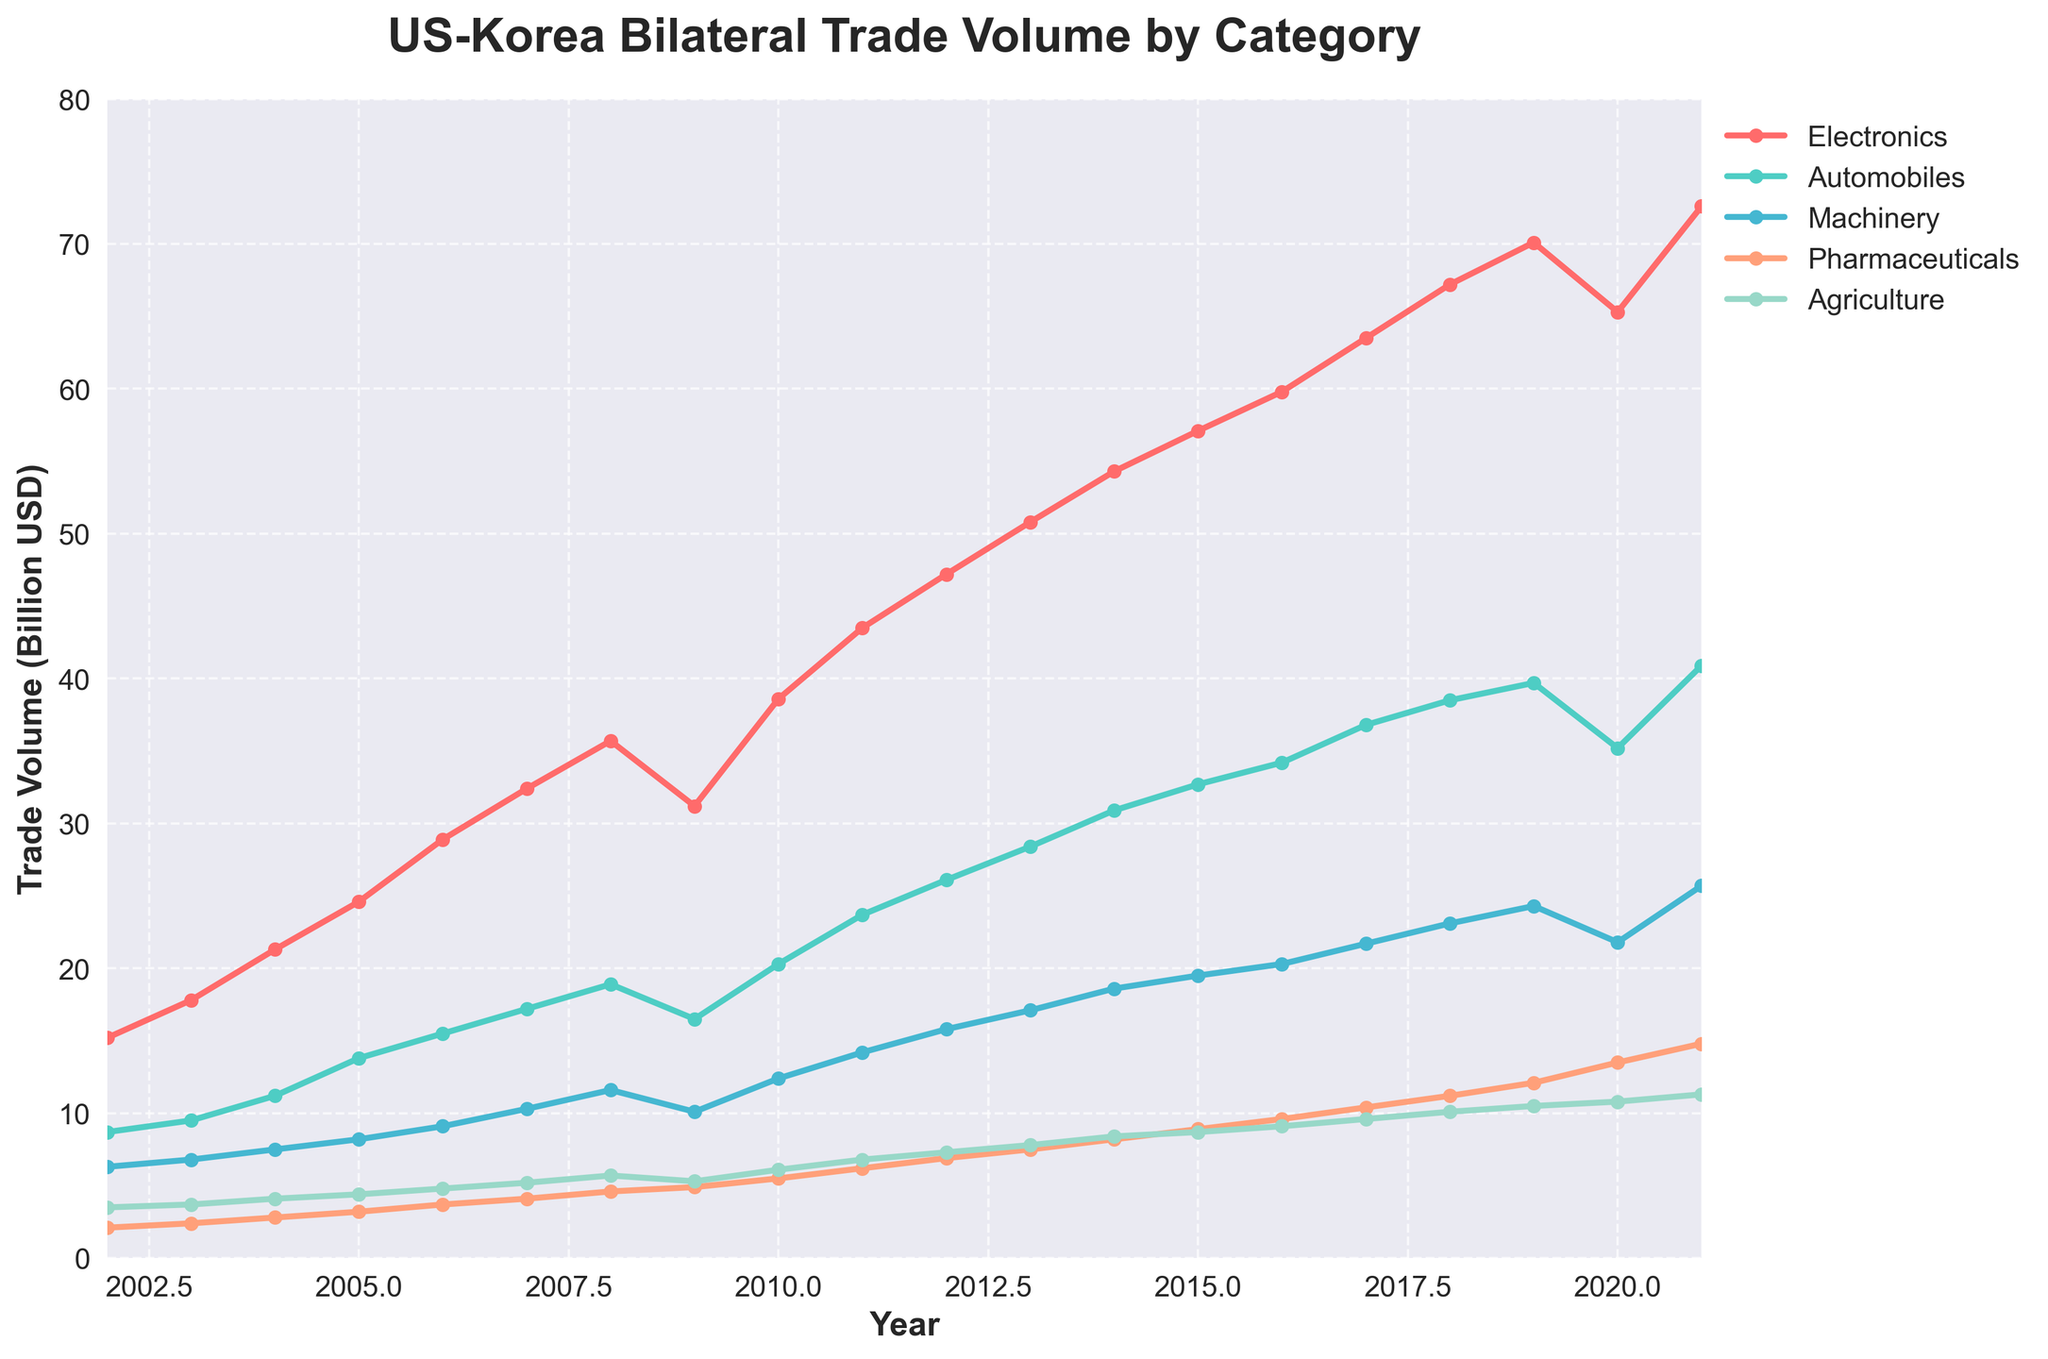Which category had the highest trade volume in 2021? By examining the line chart and the legend, we see that the 'Electronics' line reaches the highest point in 2021.
Answer: Electronics Between which two consecutive years did 'Machinery' experience the largest increase in trade volume? Observing the line for 'Machinery', the steepest increase is between 2018 and 2019, where the value rises from 23.1 to 24.3 billion USD.
Answer: 2018-2019 How did the trade volume for 'Agriculture' change from 2009 to 2010? Checking the line for 'Agriculture', the value increased from 5.3 billion USD in 2009 to 6.1 billion USD in 2010. The change is 6.1 - 5.3 = 0.8 billion USD.
Answer: Increased by 0.8 billion USD Which category showed the least fluctuation in trade volume over the period 2002-2021? By comparing the smoothness and slope variability of all lines, 'Pharmaceuticals' has the least fluctuation and shows a steady increase over time.
Answer: Pharmaceuticals What is the total trade volume for 'Electronics', 'Automobiles', and 'Machinery' in 2015? Looking at the trade volumes in 2015: Electronics: 57.1, Automobiles: 32.7, Machinery: 19.5. Summing these values, 57.1 + 32.7 + 19.5 = 109.3 billion USD.
Answer: 109.3 billion USD Which category had the steepest decline in 2020 compared to 2019? By observing the lines for all categories between 2019 and 2020, 'Electronics' shows a notable decline from 70.1 to 65.3 billion USD.
Answer: Electronics Compare the growth rates of 'Pharmaceuticals' and 'Agriculture' from 2010 to 2021. Which category had a higher growth rate? From 2010 to 2021, 'Pharmaceuticals' increased from 5.5 to 14.8 billion USD, and 'Agriculture' from 6.1 to 11.3 billion USD. Growth rates: Pharmaceuticals ((14.8-5.5)/5.5)*100 = 169.1%, Agriculture ((11.3-6.1)/6.1)*100 = 85.2%. Pharmaceuticals had a higher growth rate.
Answer: Pharmaceuticals What is the average trade volume of 'Automobiles' over the entire period? Summing 'Automobiles' volumes from 2002 to 2021: 8.7+9.5+11.2+13.8+15.5+17.2+18.9+16.5+20.3+23.7+26.1+28.4+30.9+32.7+34.2+36.8+38.5+39.7+35.2+40.9 = 495.7. Dividing by 20 years: 495.7/20 = 24.8 billion USD.
Answer: 24.8 billion USD 